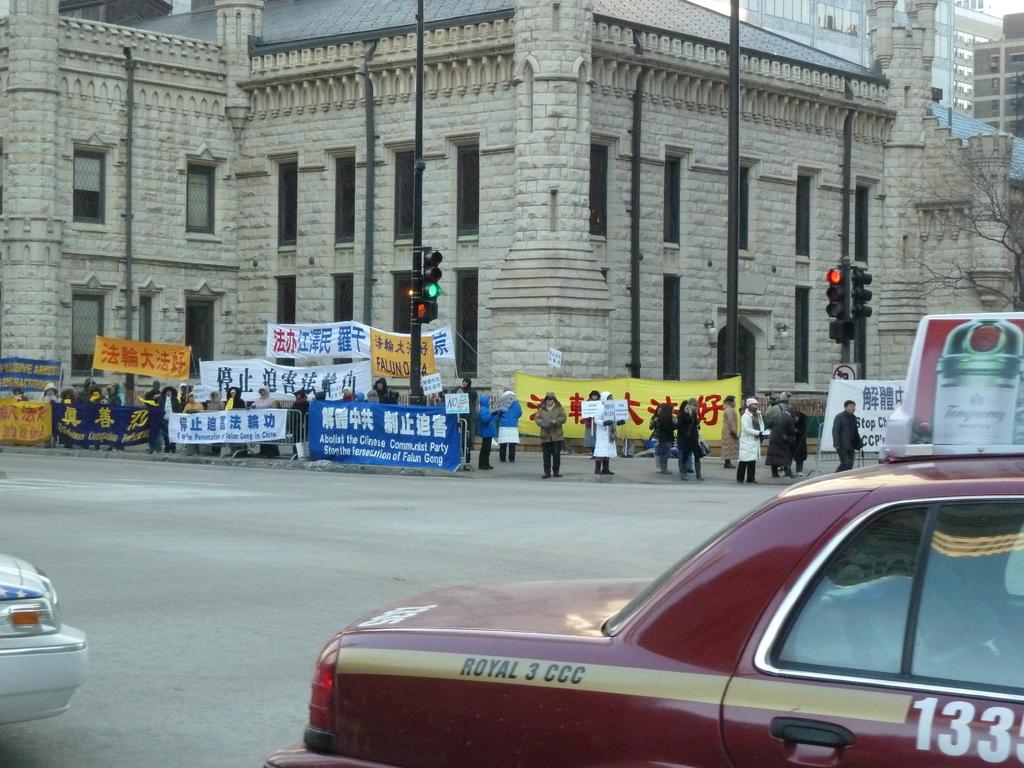Is royal 3 ccc the name of a taxi company the car's number?
Your answer should be compact. Yes. 